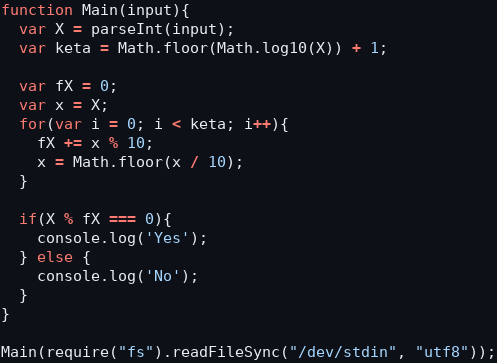Convert code to text. <code><loc_0><loc_0><loc_500><loc_500><_JavaScript_>function Main(input){
  var X = parseInt(input);
  var keta = Math.floor(Math.log10(X)) + 1;

  var fX = 0;
  var x = X;
  for(var i = 0; i < keta; i++){
    fX += x % 10;
    x = Math.floor(x / 10);
  }

  if(X % fX === 0){
    console.log('Yes');
  } else {
    console.log('No');
  }
}

Main(require("fs").readFileSync("/dev/stdin", "utf8"));</code> 